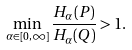Convert formula to latex. <formula><loc_0><loc_0><loc_500><loc_500>\min _ { \alpha \in [ 0 , \infty ] } \frac { H _ { \alpha } ( P ) } { H _ { \alpha } ( Q ) } > 1 .</formula> 